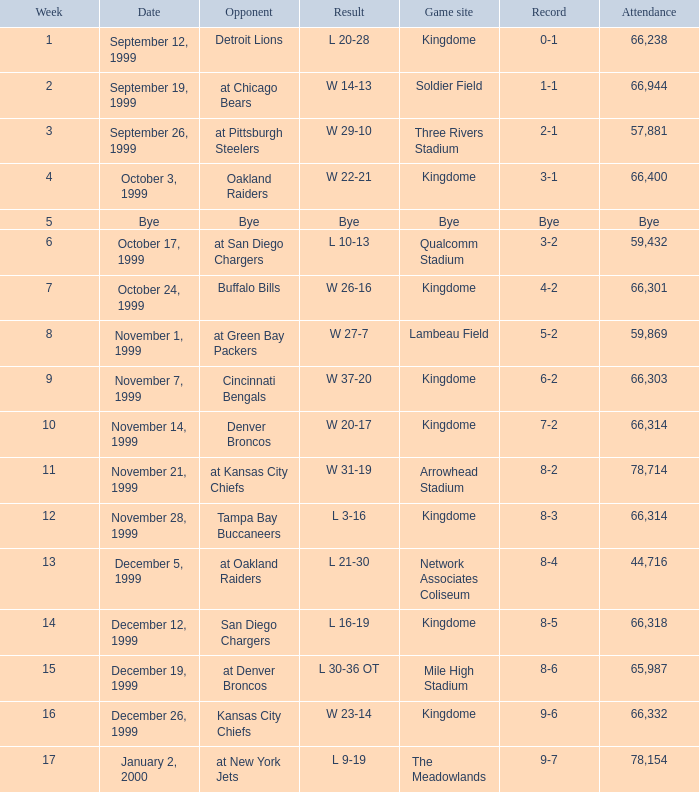What is the result of the game played during week 2? 1-1. 